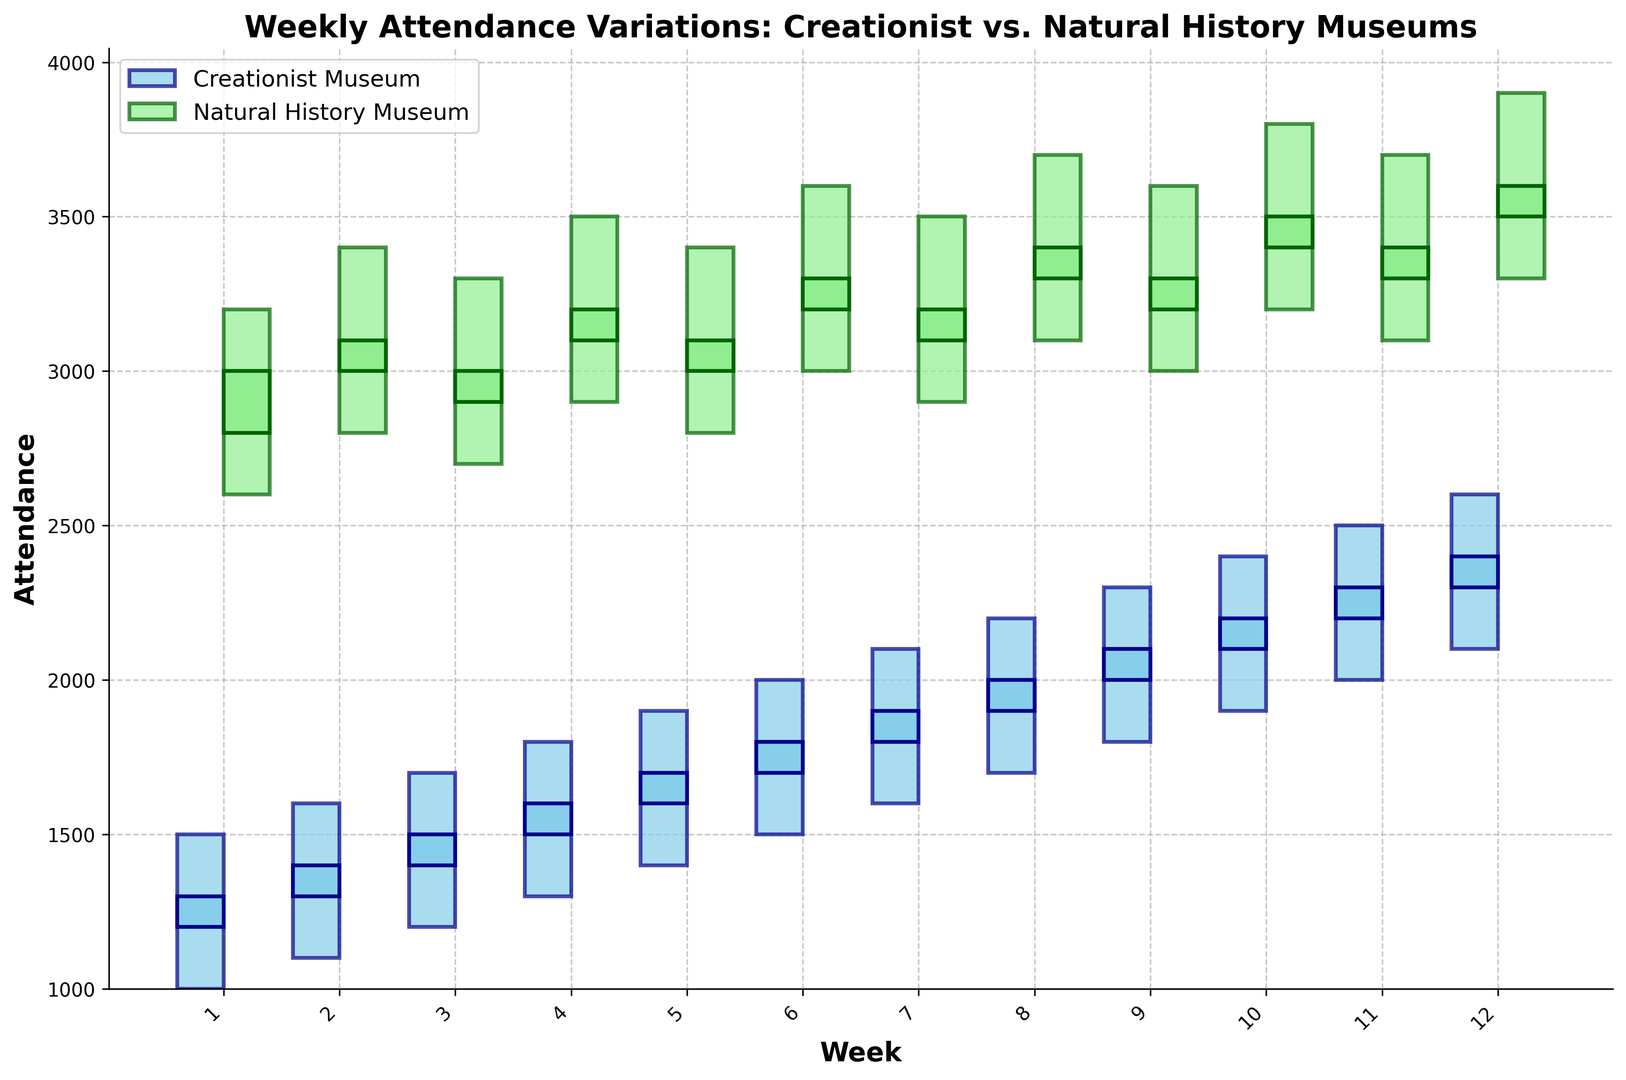Which museum has the higher attendance at Week 1's close? Observe the closing values for Week 1: Creationist Museum closes at 1300 and Natural History Museum closes at 3000. Since 3000 is greater than 1300, the Natural History Museum has the higher attendance.
Answer: Natural History Museum In which week did the Creationist Museum experience the greatest increase in weekly closing attendance? Compare the closing values week by week: Week 1 to Week 2 (1300 to 1400), Week 2 to Week 3 (1400 to 1500), and so on. The greatest increase is from Week 11 (2300) to Week 12 (2400), an increase of 100.
Answer: Week 12 What is the average attendance closure of the Natural History Museum from Week 10 to Week 12? Sum the closing values from Week 10 to Week 12 and divide by 3: (3500 + 3400 + 3600) / 3 = 3500.
Answer: 3500 Between which two weeks did the Natural History Museum's low attendance change the most? Compare the low values week to week: the highest change is from Week 3 to Week 4 (2700 to 2900), a change of 200.
Answer: Week 3 and Week 4 What was the visual difference between the candlesticks of both museums in Week 6? In Week 6, the Natural History Museum had a light green candlestick, with values (high-low) 3600-3000 and close 3300-open 3200. The Creationist Museum had a sky blue candlestick, with values (high-low) 2000-1500 and close 1800-open 1700. The sizes and colors of the visual bars are different.
Answer: Different colors and sizes 